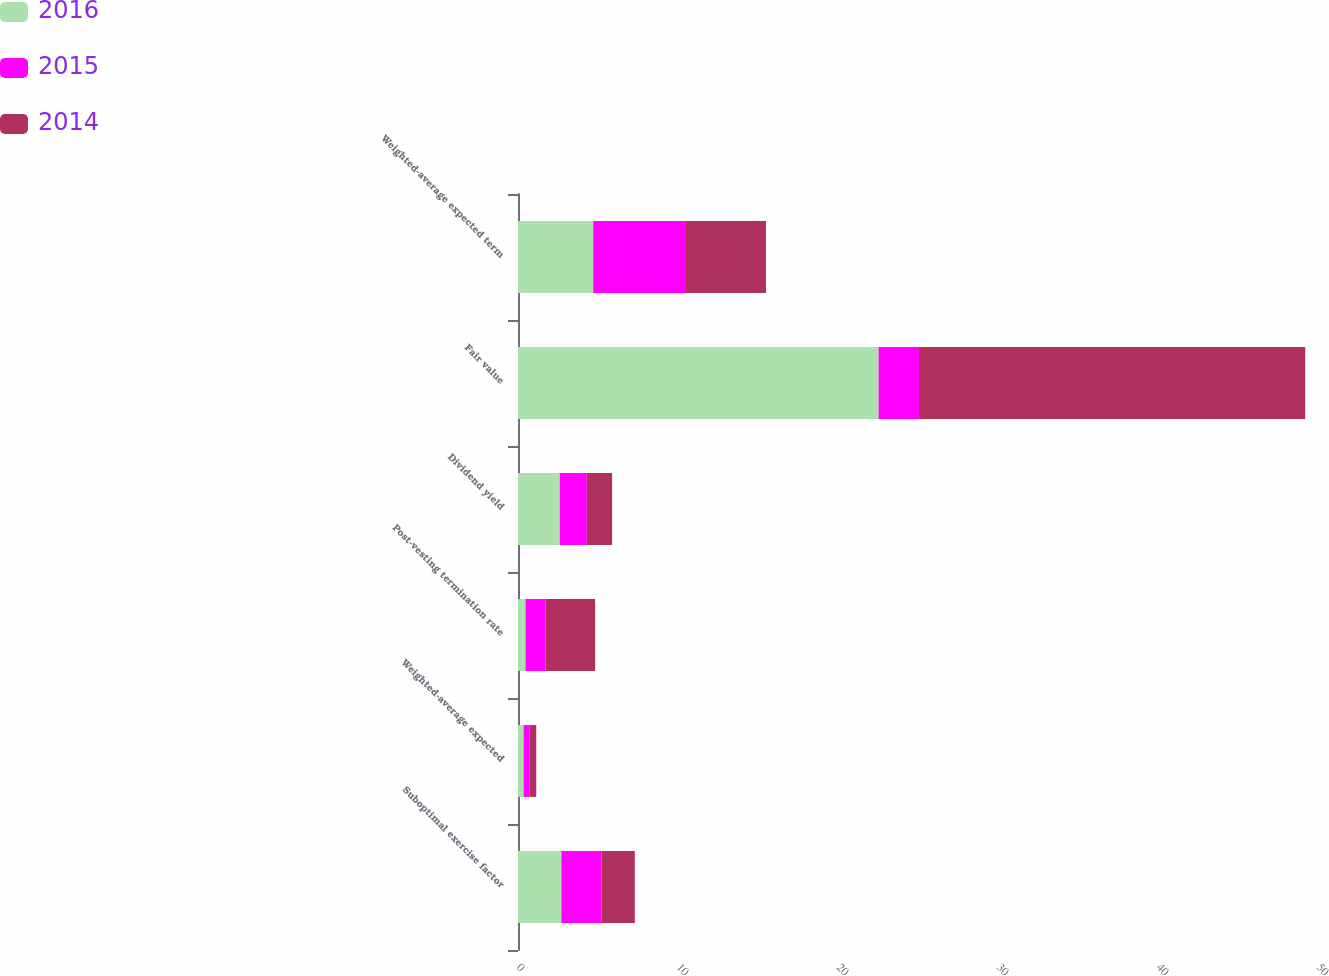<chart> <loc_0><loc_0><loc_500><loc_500><stacked_bar_chart><ecel><fcel>Suboptimal exercise factor<fcel>Weighted-average expected<fcel>Post-vesting termination rate<fcel>Dividend yield<fcel>Fair value<fcel>Weighted-average expected term<nl><fcel>2016<fcel>2.71<fcel>0.35<fcel>0.47<fcel>2.61<fcel>22.54<fcel>4.7<nl><fcel>2015<fcel>2.52<fcel>0.36<fcel>1.25<fcel>1.69<fcel>2.52<fcel>5.8<nl><fcel>2014<fcel>2.07<fcel>0.43<fcel>3.1<fcel>1.58<fcel>24.14<fcel>5<nl></chart> 